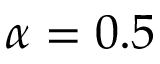<formula> <loc_0><loc_0><loc_500><loc_500>\alpha = 0 . 5</formula> 